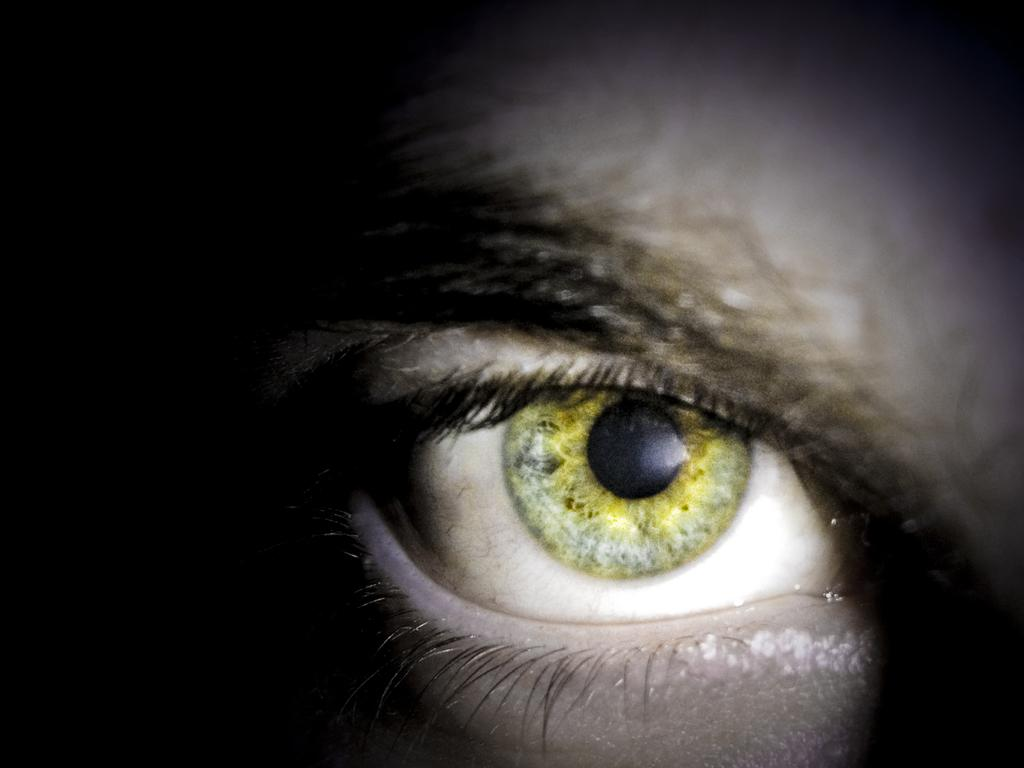What is the main subject of the image? The main subject of the image is an eye. What is located near the eye in the image? There is an eyebrow in the center of the image. Where is the vase located in the image? There is no vase present in the image. What type of engine can be seen powering the eye in the image? There is no engine present in the image, and the eye is not depicted as being powered by any mechanism. 